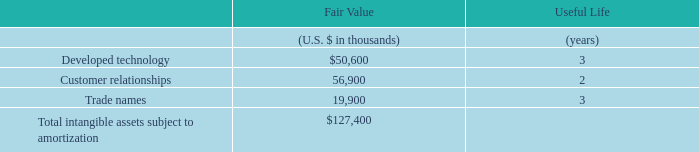The following table sets forth the components of identifiable intangible assets acquired and their estimated useful lives as of the date of acquisition.
The amount recorded for developed technology represents the estimated fair value of Trello’s project management and organization technology. The amount recorded for customer relationships represents the fair values of the underlying relationship with Trello customers.
What does the amount recorded for developed technology represent? The estimated fair value of trello’s project management and organization technology. What does the amount recorded for customer relationships represent? The fair values of the underlying relationship with trello customers. What is the useful life (in years) of developed technology? 3. What is the difference in fair value between developed technology and customer relationships?
Answer scale should be: thousand. 56,900-50,600
Answer: 6300. What are the intangible assets that have a fair value of above $20,000 thousands? For COL 3 rows 3-5 if value is >20,000 input the corresponding intangible asset component in COL2 as answer
Answer: developed technology, customer relationships. What is the percentage constitution of trade names among the total intangible assets subject to amortization?
Answer scale should be: percent. 19,900/127,400
Answer: 15.62. 